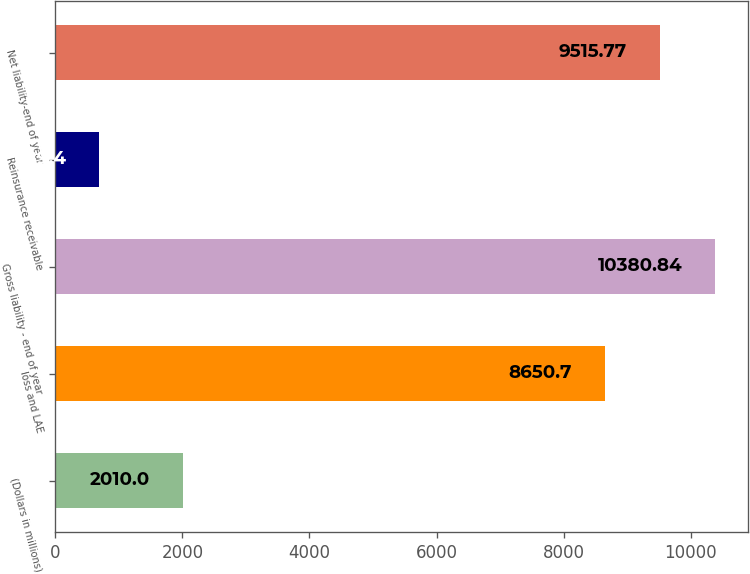Convert chart. <chart><loc_0><loc_0><loc_500><loc_500><bar_chart><fcel>(Dollars in millions)<fcel>loss and LAE<fcel>Gross liability - end of year<fcel>Reinsurance receivable<fcel>Net liability-end of year<nl><fcel>2010<fcel>8650.7<fcel>10380.8<fcel>689.4<fcel>9515.77<nl></chart> 